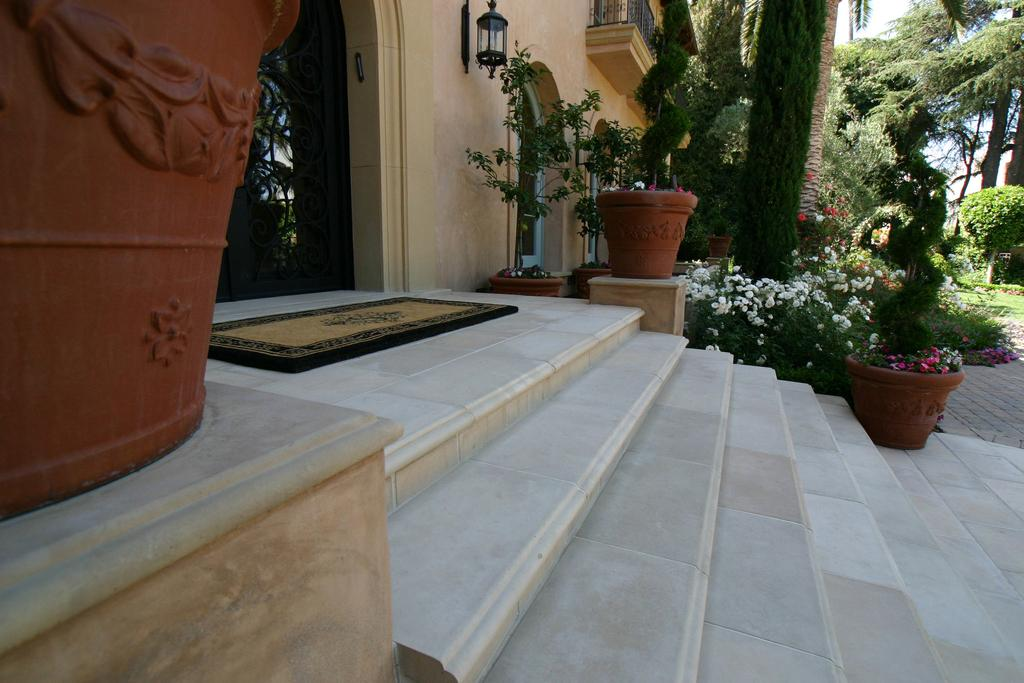What is located at the entrance of the building in the image? There is a doormat in the image. What architectural feature is present in the image? There are steps in the image. What type of vegetation can be seen in the image? House plants and flowers are present in the image. What lighting fixture is visible in the image? There is a lamp in the image. What structural element is present in the image? There is a wall in the image. What safety feature is present in the image? There is a railing in the image. What can be seen through the windows in the image? Windows are visible in the image. How many objects are mentioned in the facts? There are 10 objects mentioned in the facts. What type of vegetation is visible in the background of the image? Trees are visible in the background of the image. Where is the zebra crossing the road in the image? There is no zebra or road present in the image. What type of liquid is visible in the image? There is no liquid visible in the image. 